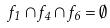<formula> <loc_0><loc_0><loc_500><loc_500>f _ { 1 } \cap f _ { 4 } \cap f _ { 6 } = \emptyset</formula> 